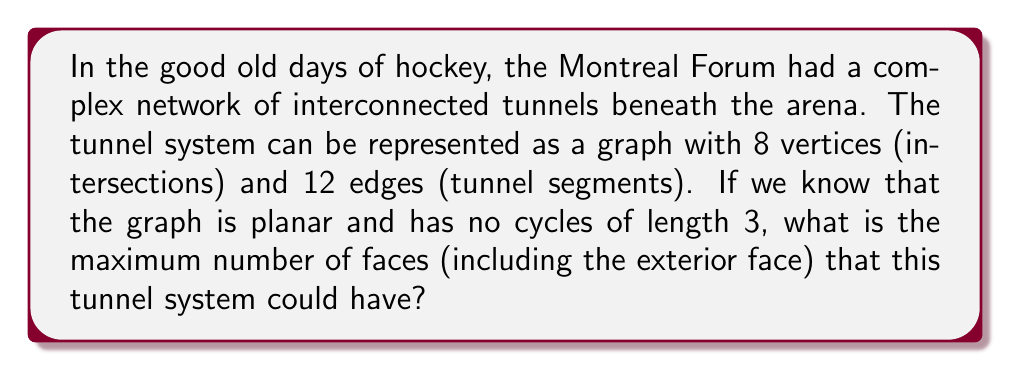Solve this math problem. Let's approach this step-by-step using Euler's formula and the given information:

1) We're given that the graph is planar, has 8 vertices (V), and 12 edges (E).

2) We need to find the maximum number of faces (F).

3) Euler's formula for planar graphs states: $V - E + F = 2$

4) We can rearrange this to solve for F: $F = 2 - V + E = 2 - 8 + 12 = 6$

5) However, this is not necessarily the maximum number of faces. We need to consider the constraint that there are no cycles of length 3 (triangles).

6) In a planar graph, the maximum number of faces occurs when all faces (except possibly the exterior face) have the minimum possible number of edges.

7) Since there are no triangles, the minimum number of edges per face is 4.

8) Let $x$ be the number of faces. Then, counting each edge for the two faces it borders:

   $4x \leq 2E$

9) Substituting $E = 12$:

   $4x \leq 24$
   $x \leq 6$

10) This upper bound of 6 faces matches our calculation from Euler's formula.

Therefore, the maximum number of faces is indeed 6.
Answer: 6 faces 